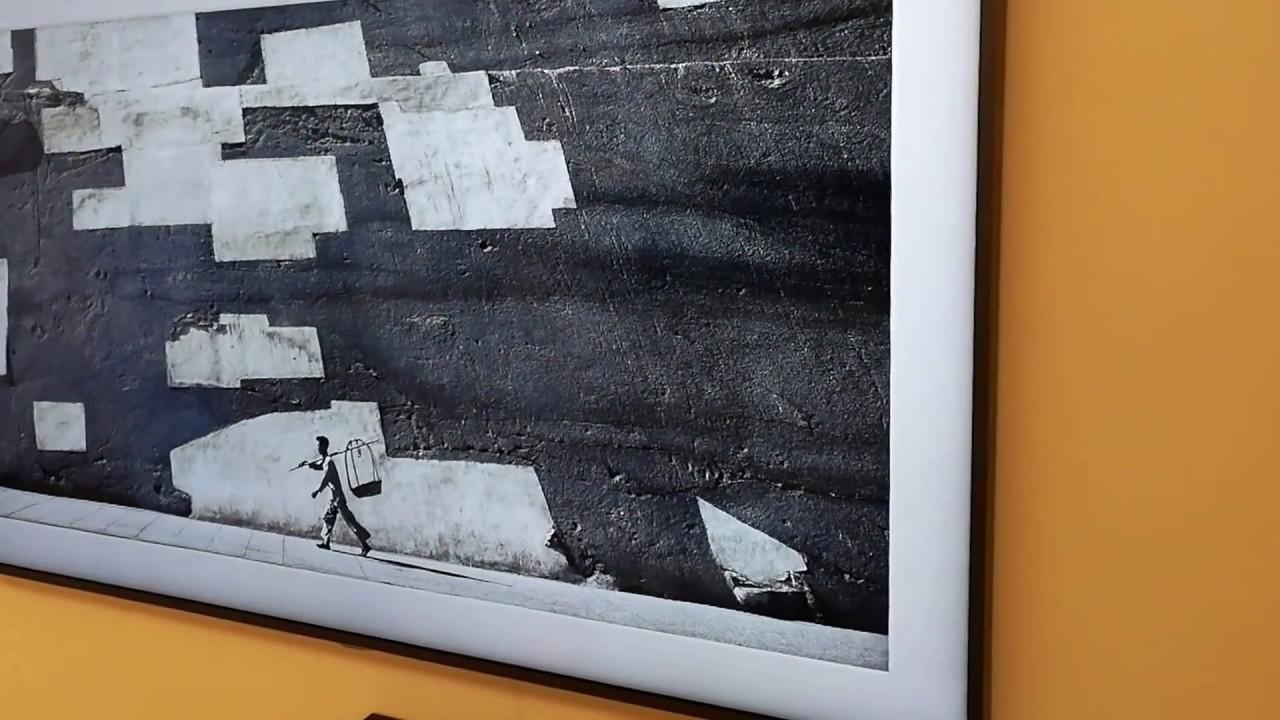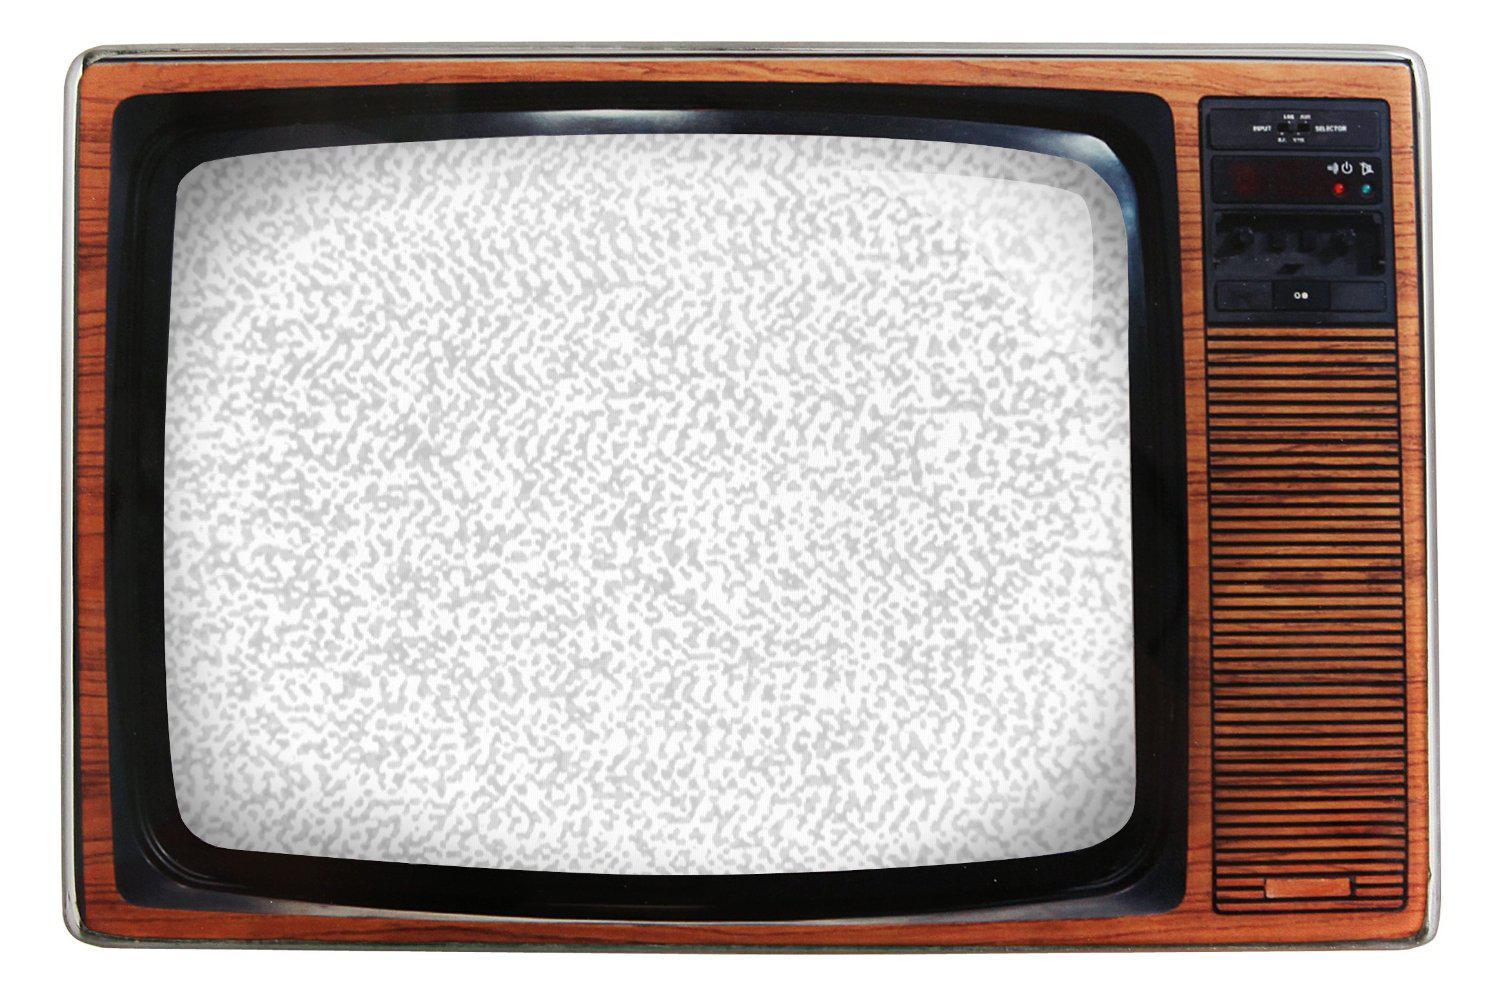The first image is the image on the left, the second image is the image on the right. Considering the images on both sides, is "A portable television has a vertical control area to one side, with two large knobs at the top, and a small speaker area below." valid? Answer yes or no. No. The first image is the image on the left, the second image is the image on the right. Assess this claim about the two images: "A frame is mounted to a wall in the image on the left.". Correct or not? Answer yes or no. Yes. 